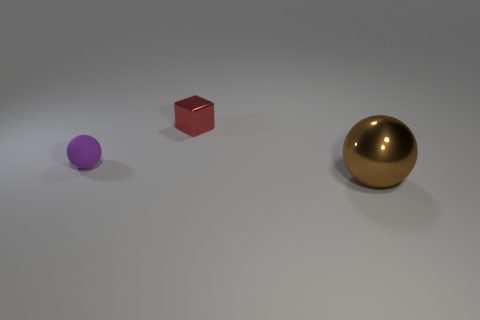Does the thing that is behind the small purple matte object have the same material as the large brown sphere?
Your response must be concise. Yes. What material is the red cube that is the same size as the purple object?
Ensure brevity in your answer.  Metal. What number of other objects are the same material as the big brown thing?
Ensure brevity in your answer.  1. Is the size of the red object the same as the ball that is behind the brown thing?
Give a very brief answer. Yes. Are there fewer big balls that are to the left of the metal sphere than metal things in front of the tiny purple object?
Your answer should be compact. Yes. What size is the ball behind the brown shiny ball?
Provide a succinct answer. Small. Do the red metallic object and the brown ball have the same size?
Offer a very short reply. No. How many objects are on the right side of the red metal object and on the left side of the red thing?
Your answer should be very brief. 0. What number of yellow objects are big shiny balls or shiny things?
Provide a succinct answer. 0. What number of rubber things are large things or large blue cylinders?
Your response must be concise. 0. 